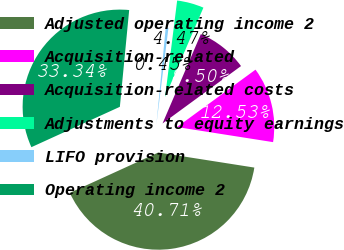Convert chart. <chart><loc_0><loc_0><loc_500><loc_500><pie_chart><fcel>Adjusted operating income 2<fcel>Acquisition-related<fcel>Acquisition-related costs<fcel>Adjustments to equity earnings<fcel>LIFO provision<fcel>Operating income 2<nl><fcel>40.71%<fcel>12.53%<fcel>8.5%<fcel>4.47%<fcel>0.45%<fcel>33.34%<nl></chart> 